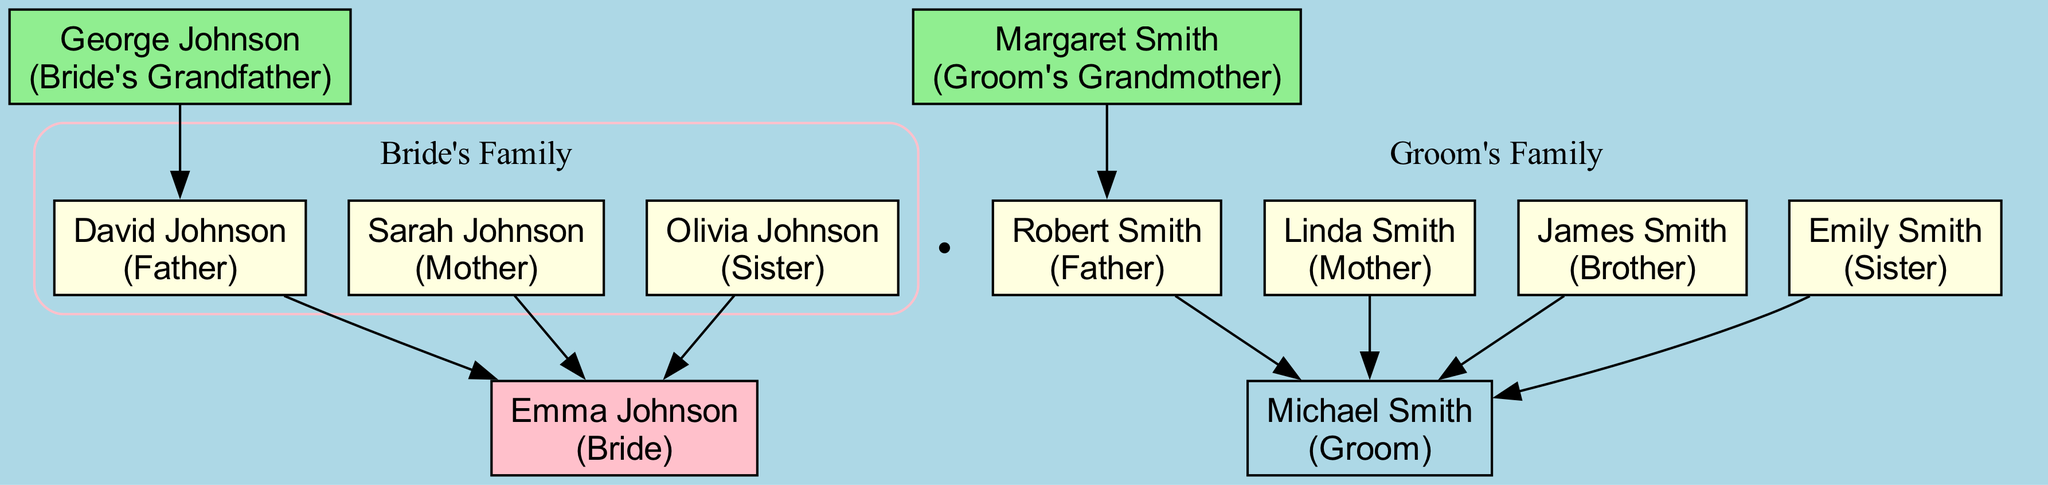What is the name of the bride? The diagram clearly shows the node labeled "Emma Johnson" under the section for the bride, indicating her full name.
Answer: Emma Johnson Who are the groom's siblings? Looking under the groom's family section, there are two nodes for siblings: "James Smith" and "Emily Smith," which are labeled with their respective relationships.
Answer: James Smith, Emily Smith How many grandparents are represented in the family tree? The grandparents' section contains two nodes, one for "George Johnson" and one for "Margaret Smith," making a total of two grandparents in the diagram.
Answer: 2 What is the relationship of Sarah Johnson to Emma Johnson? In the diagram, "Sarah Johnson" is listed under the bride's family with the label "Mother," which directly indicates her relationship to Emma Johnson.
Answer: Mother Which grandparent belongs to the bride's side of the family? The diagram includes "George Johnson," labeled as "Bride's Grandfather," which identifies him as the grandparent on Emma's side of the family.
Answer: George Johnson How many family members attended from the groom's side? Counting the nodes in the groom's family section, there are four members noted: "Robert Smith," "Linda Smith," "James Smith," and "Emily Smith." This indicates the total number of family members from the groom's side.
Answer: 4 What is the relation of David Johnson to Emma Johnson? The diagram shows "David Johnson" under the bride's family with the label "Father," which indicates that David Johnson is Emma Johnson's father.
Answer: Father How many sisters are represented in the family tree? In the family's sections, "Olivia Johnson" is listed as a sister from the bride's side, and "Emily Smith" is listed as a sister from the groom's side, totaling two sisters in the diagram.
Answer: 2 What color represents the bride's family in the diagram? The cluster containing the bride's family is enveloped in a pink label and section, indicating that pink is the color associated with the bride's family.
Answer: Pink 